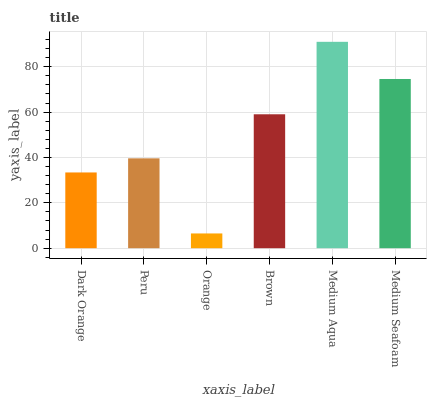Is Orange the minimum?
Answer yes or no. Yes. Is Medium Aqua the maximum?
Answer yes or no. Yes. Is Peru the minimum?
Answer yes or no. No. Is Peru the maximum?
Answer yes or no. No. Is Peru greater than Dark Orange?
Answer yes or no. Yes. Is Dark Orange less than Peru?
Answer yes or no. Yes. Is Dark Orange greater than Peru?
Answer yes or no. No. Is Peru less than Dark Orange?
Answer yes or no. No. Is Brown the high median?
Answer yes or no. Yes. Is Peru the low median?
Answer yes or no. Yes. Is Peru the high median?
Answer yes or no. No. Is Brown the low median?
Answer yes or no. No. 